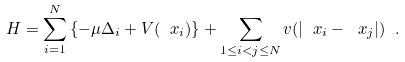<formula> <loc_0><loc_0><loc_500><loc_500>H = \sum _ { i = 1 } ^ { N } \left \{ - \mu \Delta _ { i } + V ( \ x _ { i } ) \right \} + \sum _ { 1 \leq i < j \leq N } v ( | \ x _ { i } - \ x _ { j } | ) \ .</formula> 